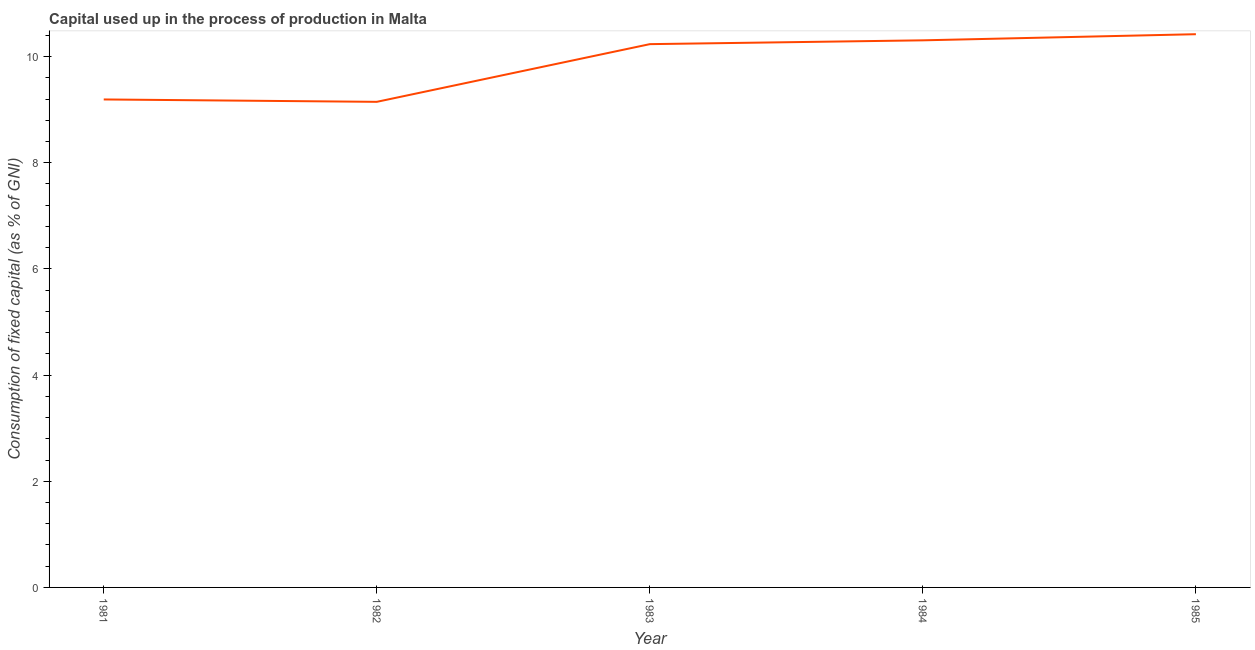What is the consumption of fixed capital in 1984?
Provide a short and direct response. 10.31. Across all years, what is the maximum consumption of fixed capital?
Offer a very short reply. 10.42. Across all years, what is the minimum consumption of fixed capital?
Offer a terse response. 9.15. In which year was the consumption of fixed capital maximum?
Keep it short and to the point. 1985. In which year was the consumption of fixed capital minimum?
Your answer should be compact. 1982. What is the sum of the consumption of fixed capital?
Give a very brief answer. 49.3. What is the difference between the consumption of fixed capital in 1981 and 1983?
Provide a short and direct response. -1.04. What is the average consumption of fixed capital per year?
Provide a succinct answer. 9.86. What is the median consumption of fixed capital?
Keep it short and to the point. 10.23. In how many years, is the consumption of fixed capital greater than 2 %?
Keep it short and to the point. 5. What is the ratio of the consumption of fixed capital in 1981 to that in 1985?
Offer a terse response. 0.88. What is the difference between the highest and the second highest consumption of fixed capital?
Your answer should be compact. 0.12. What is the difference between the highest and the lowest consumption of fixed capital?
Your answer should be compact. 1.27. In how many years, is the consumption of fixed capital greater than the average consumption of fixed capital taken over all years?
Give a very brief answer. 3. Are the values on the major ticks of Y-axis written in scientific E-notation?
Offer a terse response. No. What is the title of the graph?
Offer a very short reply. Capital used up in the process of production in Malta. What is the label or title of the X-axis?
Provide a succinct answer. Year. What is the label or title of the Y-axis?
Your answer should be very brief. Consumption of fixed capital (as % of GNI). What is the Consumption of fixed capital (as % of GNI) of 1981?
Offer a terse response. 9.19. What is the Consumption of fixed capital (as % of GNI) in 1982?
Give a very brief answer. 9.15. What is the Consumption of fixed capital (as % of GNI) in 1983?
Your response must be concise. 10.23. What is the Consumption of fixed capital (as % of GNI) of 1984?
Provide a short and direct response. 10.31. What is the Consumption of fixed capital (as % of GNI) of 1985?
Your answer should be very brief. 10.42. What is the difference between the Consumption of fixed capital (as % of GNI) in 1981 and 1982?
Offer a terse response. 0.04. What is the difference between the Consumption of fixed capital (as % of GNI) in 1981 and 1983?
Give a very brief answer. -1.04. What is the difference between the Consumption of fixed capital (as % of GNI) in 1981 and 1984?
Provide a succinct answer. -1.11. What is the difference between the Consumption of fixed capital (as % of GNI) in 1981 and 1985?
Make the answer very short. -1.23. What is the difference between the Consumption of fixed capital (as % of GNI) in 1982 and 1983?
Your answer should be compact. -1.09. What is the difference between the Consumption of fixed capital (as % of GNI) in 1982 and 1984?
Keep it short and to the point. -1.16. What is the difference between the Consumption of fixed capital (as % of GNI) in 1982 and 1985?
Offer a terse response. -1.27. What is the difference between the Consumption of fixed capital (as % of GNI) in 1983 and 1984?
Offer a terse response. -0.07. What is the difference between the Consumption of fixed capital (as % of GNI) in 1983 and 1985?
Ensure brevity in your answer.  -0.19. What is the difference between the Consumption of fixed capital (as % of GNI) in 1984 and 1985?
Ensure brevity in your answer.  -0.12. What is the ratio of the Consumption of fixed capital (as % of GNI) in 1981 to that in 1983?
Make the answer very short. 0.9. What is the ratio of the Consumption of fixed capital (as % of GNI) in 1981 to that in 1984?
Keep it short and to the point. 0.89. What is the ratio of the Consumption of fixed capital (as % of GNI) in 1981 to that in 1985?
Ensure brevity in your answer.  0.88. What is the ratio of the Consumption of fixed capital (as % of GNI) in 1982 to that in 1983?
Provide a short and direct response. 0.89. What is the ratio of the Consumption of fixed capital (as % of GNI) in 1982 to that in 1984?
Offer a very short reply. 0.89. What is the ratio of the Consumption of fixed capital (as % of GNI) in 1982 to that in 1985?
Your answer should be compact. 0.88. What is the ratio of the Consumption of fixed capital (as % of GNI) in 1983 to that in 1985?
Provide a succinct answer. 0.98. What is the ratio of the Consumption of fixed capital (as % of GNI) in 1984 to that in 1985?
Your response must be concise. 0.99. 